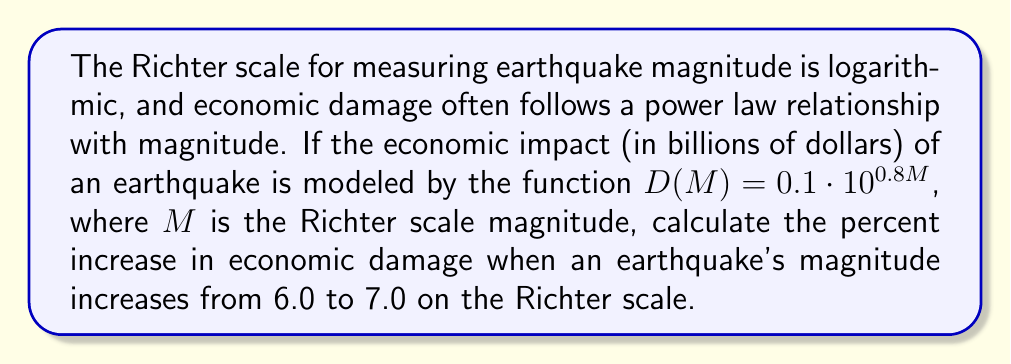What is the answer to this math problem? 1) First, let's calculate the economic damage for an earthquake with magnitude 6.0:
   $D(6.0) = 0.1 \cdot 10^{0.8(6.0)} = 0.1 \cdot 10^{4.8} = 6.31$ billion dollars

2) Now, let's calculate the economic damage for an earthquake with magnitude 7.0:
   $D(7.0) = 0.1 \cdot 10^{0.8(7.0)} = 0.1 \cdot 10^{5.6} = 39.81$ billion dollars

3) To find the percent increase, we use the formula:
   Percent increase = $\frac{\text{Increase}}{\text{Original}} \times 100\%$

4) The increase in damage is:
   $39.81 - 6.31 = 33.5$ billion dollars

5) Calculate the percent increase:
   Percent increase = $\frac{33.5}{6.31} \times 100\% = 530.9\%$

6) Round to the nearest whole percent:
   Percent increase ≈ 531%
Answer: 531% 